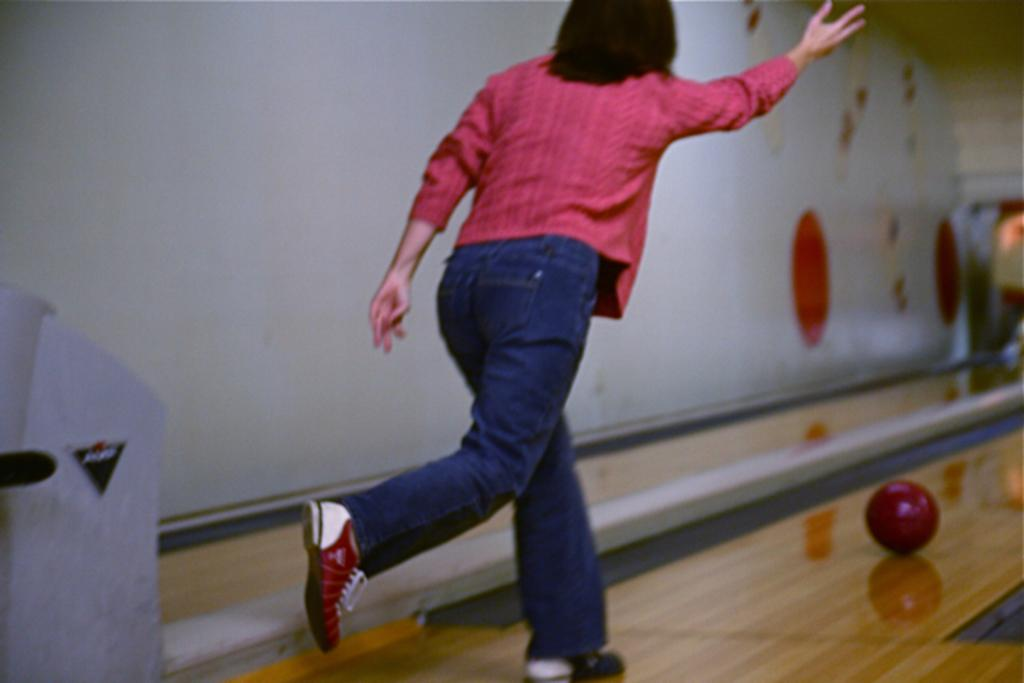Who is present in the image? There is a lady in the image. What type of flooring is visible at the bottom of the image? There is wooden flooring at the bottom of the image. What object can be seen in the image? There is a ball in the image. What is visible in the background of the image? There is a wall in the background of the image. Is there a spy hiding behind the wall in the image? There is no indication of a spy or any hidden figure in the image; it only shows a lady, a ball, and a wall. 